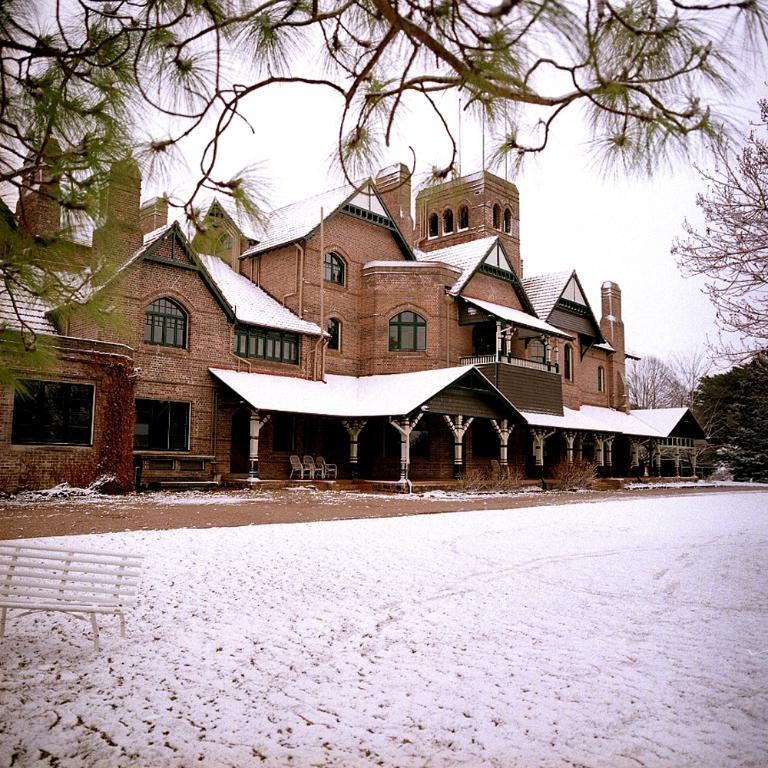What type of structure is visible in the image? There is a building in the image. What architectural features can be seen on the building? The building has windows and pillars. What type of furniture is present inside the building? There are chairs in the building. What is located on the right side of the image? There is a bench on the right side of the image. What natural element is visible in the image? There is a branch in the image. How many chains are hanging from the ceiling in the image? There are no chains visible in the image. What type of trees can be seen through the windows of the building? There is no indication of trees being visible through the windows in the image. 